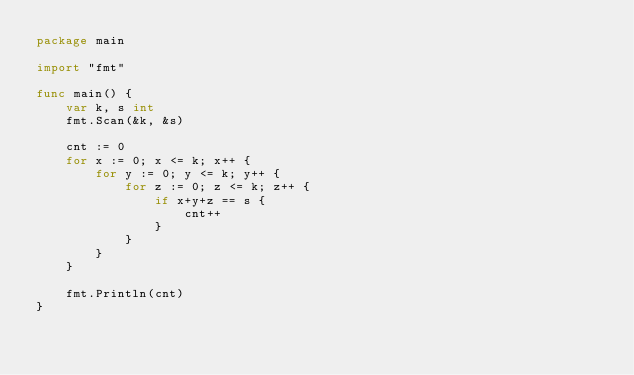Convert code to text. <code><loc_0><loc_0><loc_500><loc_500><_Go_>package main

import "fmt"

func main() {
	var k, s int
	fmt.Scan(&k, &s)

	cnt := 0
	for x := 0; x <= k; x++ {
		for y := 0; y <= k; y++ {
			for z := 0; z <= k; z++ {
				if x+y+z == s {
					cnt++
				}
			}
		}
	}

	fmt.Println(cnt)
}
</code> 